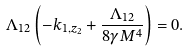Convert formula to latex. <formula><loc_0><loc_0><loc_500><loc_500>\Lambda _ { 1 2 } \left ( - k _ { 1 , z _ { 2 } } + \frac { \Lambda _ { 1 2 } } { 8 \gamma M ^ { 4 } } \right ) = 0 .</formula> 